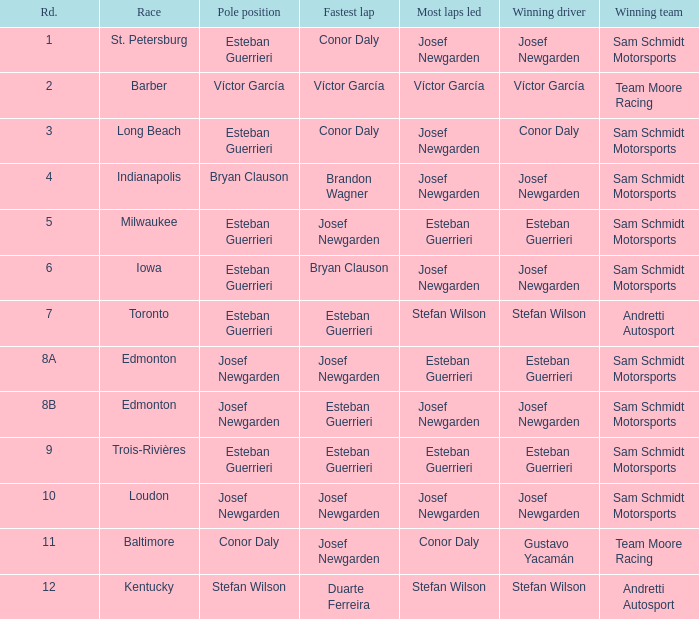During which event did josef newgarden achieve the speediest lap and lead the highest number of laps? Loudon. 